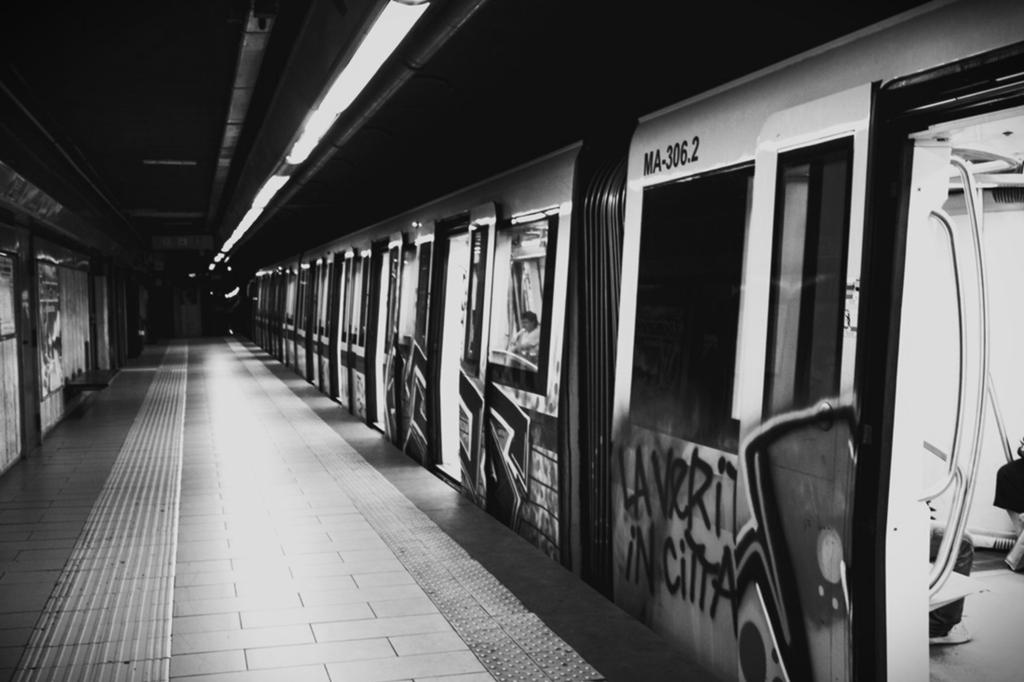What mode of transportation can be seen on the right side of the image? There is a train on the right side of the image. Where is the train located in the image? The train is on a railway track. What is present on the left side of the image? There is a railway platform on the left side of the image. Can you tell me how many tigers are playing chess on the railway platform in the image? There are no tigers or chess games present on the railway platform in the image. 